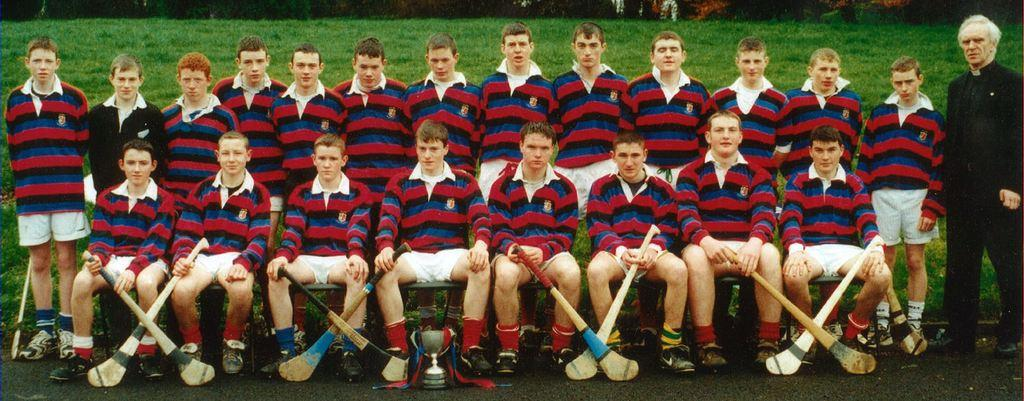How many people are in the image? There is a group of people in the image, but the exact number is not specified. What is the setting of the image? The people are on a grassy land. What type of vein is visible in the image? There is no vein present in the image. How does the steam affect the people in the image? There is no steam present in the image. 